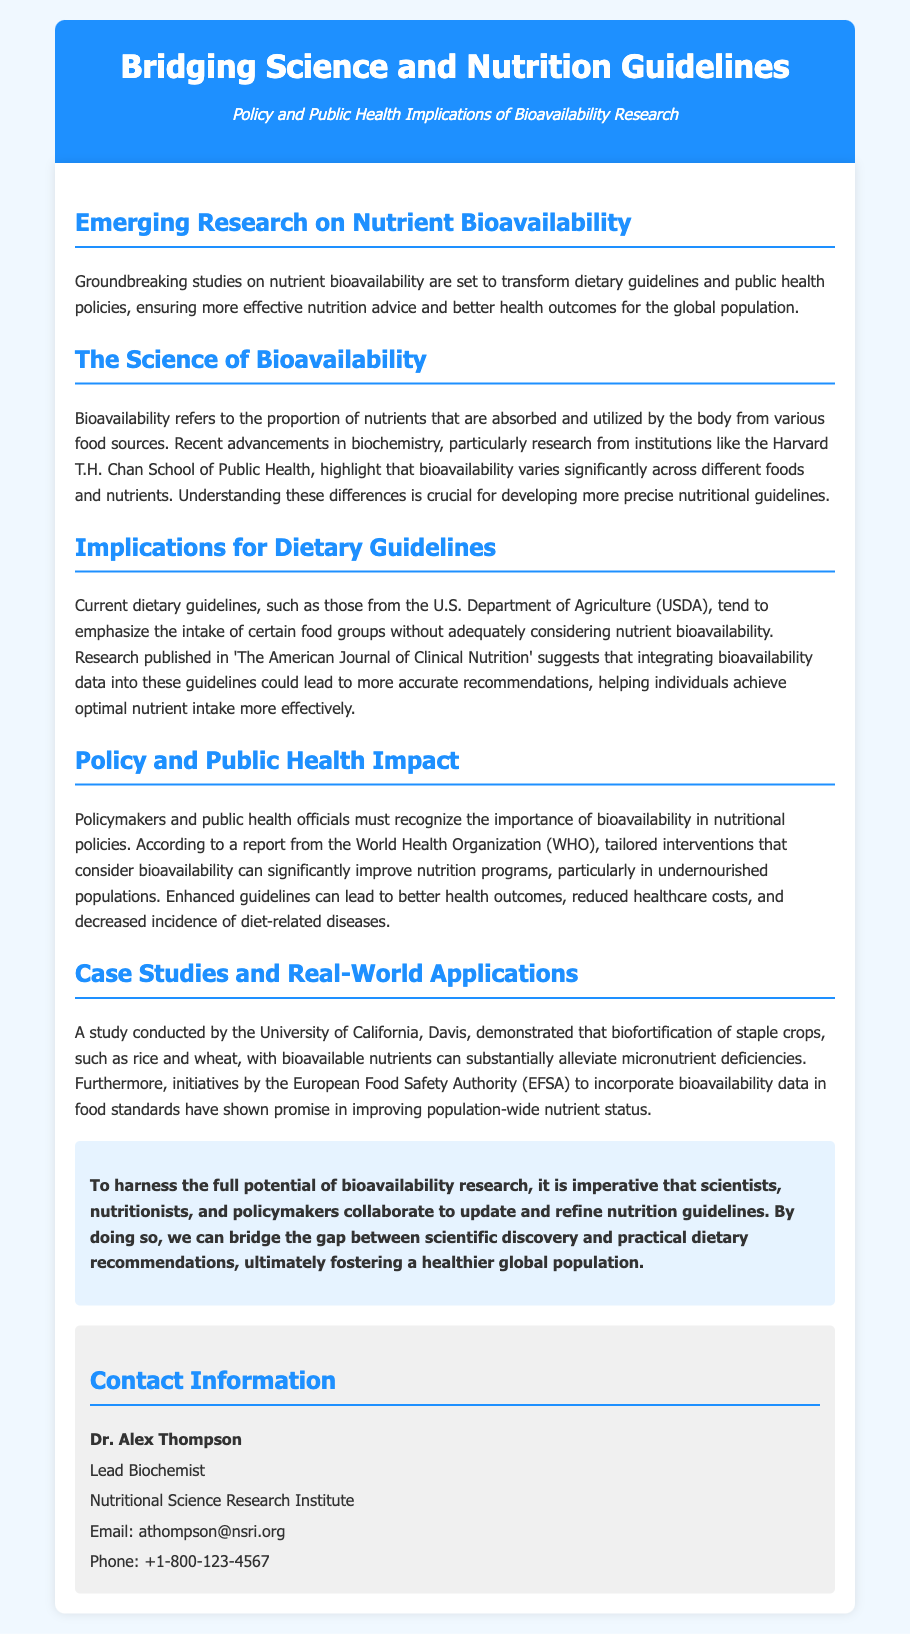what is the title of the press release? The title of the press release is emphasized in the header section and reflects the overarching theme of the document.
Answer: Bridging Science and Nutrition Guidelines who is the lead biochemist mentioned in the document? The document contains a section providing contact information, listing the lead biochemist's name and role.
Answer: Dr. Alex Thompson which institution conducted a significant study on nutrient bioavailability? The document highlights research conducted by particular institutions, specifying those that have made important contributions to the field.
Answer: Harvard T.H. Chan School of Public Health what dietary guidelines organization is referenced? The document refers to an authoritative organization responsible for creating dietary guidelines, identifiable in the implications section.
Answer: U.S. Department of Agriculture (USDA) which crops were demonstrated to benefit from biofortification in case studies? The document provides examples of specific staple crops that were involved in the study of biofortification.
Answer: rice and wheat how can bioavailability research impact public health? The document mentions specific positive outcomes that can result from integrating bioavailability data into public health policies.
Answer: improved nutrition programs what is the potential benefit of integrating bioavailability data into dietary guidelines? The document states the expected improvement in nutritional recommendations when bioavailability is considered, indicating its significance.
Answer: more accurate recommendations which organization conducted initiatives to incorporate bioavailability data in food standards? This organization is noted in the case studies section as having taken specific actions related to food standards and nutrient status improvement.
Answer: European Food Safety Authority (EFSA) 